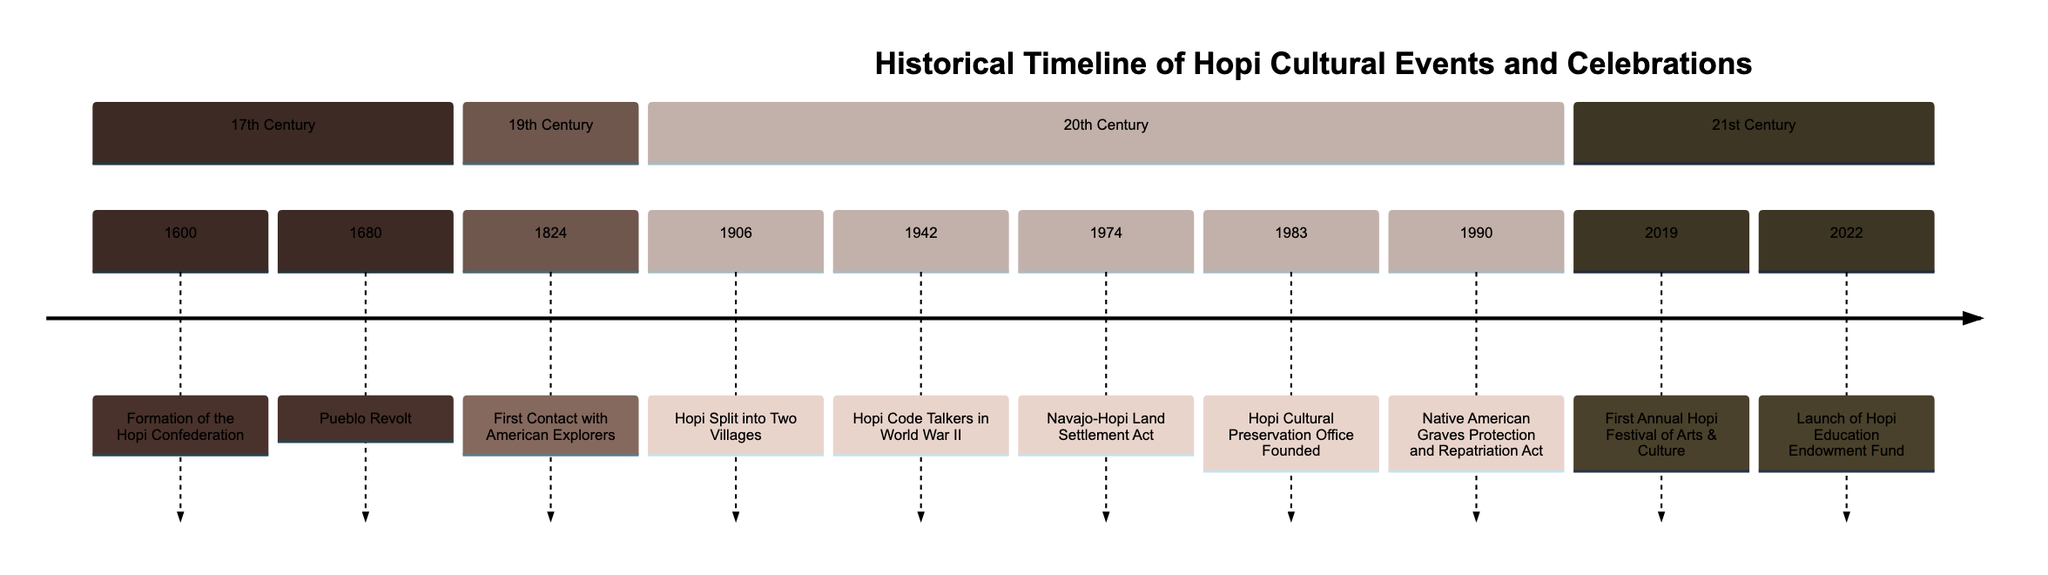What is the earliest event listed in the timeline? The first event listed in the timeline is from the year 1600, which is the formation of the Hopi Confederation.
Answer: Formation of the Hopi Confederation How many events are there in the 20th century? Counting the events listed under the 20th Century section, there are six events: Hopi Split into Two Villages, Hopi Code Talkers in World War II, Navajo-Hopi Land Settlement Act, Hopi Cultural Preservation Office Founded, and Native American Graves Protection and Repatriation Act.
Answer: 6 What significant event occurred in 1942? According to the timeline, the significant event in 1942 was the involvement of Hopi Code Talkers in World War II.
Answer: Hopi Code Talkers in World War II What decade did the Hopi Cultural Preservation Office get founded? The Hopi Cultural Preservation Office was founded in 1983, which is in the 1980s.
Answer: 1980s Which event directly follows the Pueblo Revolt in the timeline? The event that directly follows the Pueblo Revolt in 1680 is the First Contact with American Explorers in 1824.
Answer: First Contact with American Explorers How many events took place in the 21st century? The timeline indicates two events took place in the 21st century: the First Annual Hopi Festival of Arts & Culture in 2019 and the Launch of Hopi Education Endowment Fund in 2022.
Answer: 2 What was the purpose of the Navajo-Hopi Land Settlement Act? The purpose of the Navajo-Hopi Land Settlement Act, enacted in 1974, was related to land disputes and forced relocations between Hopi and Navajo families.
Answer: Land disputes and forced relocations What cultural initiative was launched in 2022? The cultural initiative launched in 2022 was the Hopi Education Endowment Fund, aimed at providing scholarships and educational resources.
Answer: Hopi Education Endowment Fund 